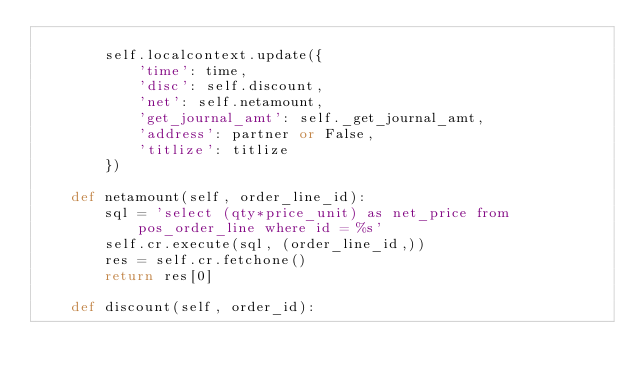<code> <loc_0><loc_0><loc_500><loc_500><_Python_>
        self.localcontext.update({
            'time': time,
            'disc': self.discount,
            'net': self.netamount,
            'get_journal_amt': self._get_journal_amt,
            'address': partner or False,
            'titlize': titlize
        })

    def netamount(self, order_line_id):
        sql = 'select (qty*price_unit) as net_price from pos_order_line where id = %s'
        self.cr.execute(sql, (order_line_id,))
        res = self.cr.fetchone()
        return res[0]

    def discount(self, order_id):</code> 